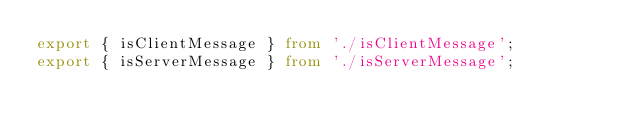Convert code to text. <code><loc_0><loc_0><loc_500><loc_500><_TypeScript_>export { isClientMessage } from './isClientMessage';
export { isServerMessage } from './isServerMessage';</code> 